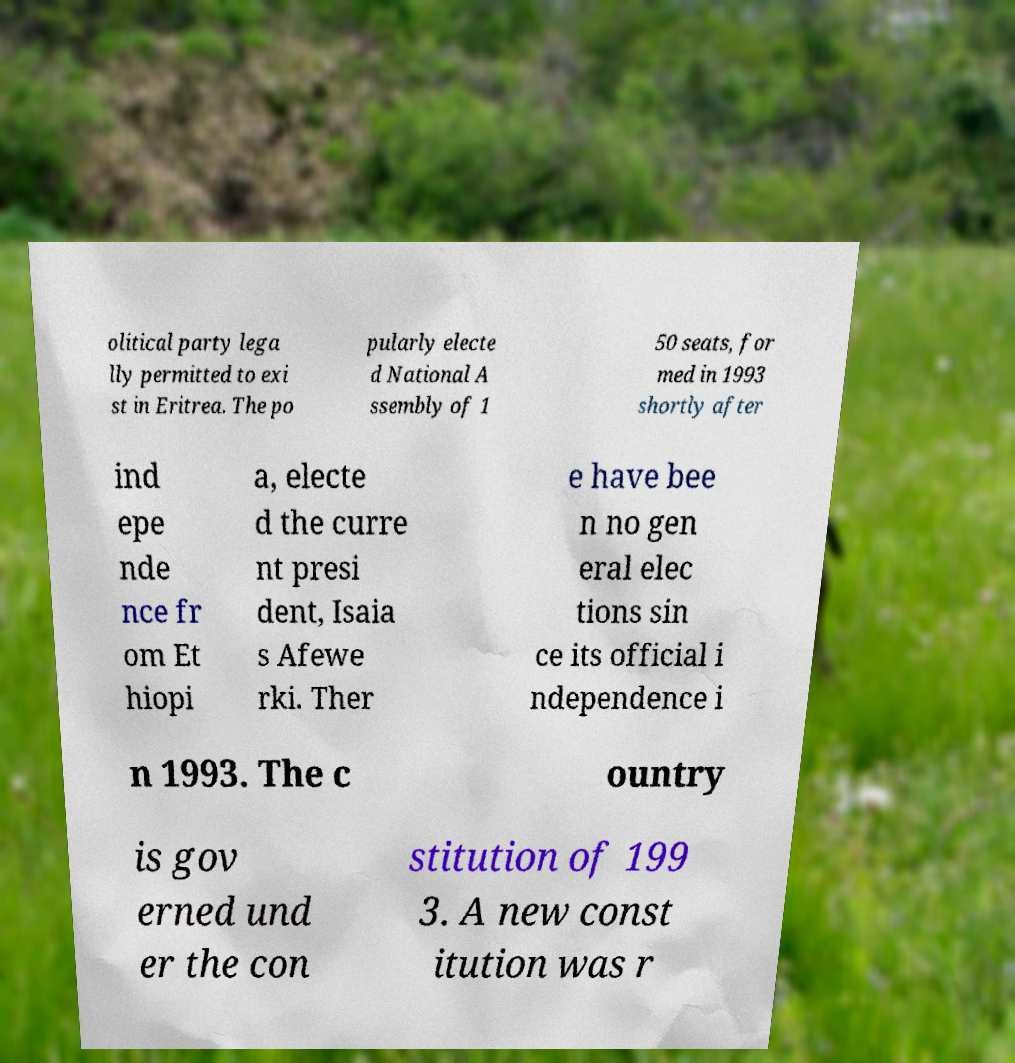Can you read and provide the text displayed in the image?This photo seems to have some interesting text. Can you extract and type it out for me? olitical party lega lly permitted to exi st in Eritrea. The po pularly electe d National A ssembly of 1 50 seats, for med in 1993 shortly after ind epe nde nce fr om Et hiopi a, electe d the curre nt presi dent, Isaia s Afewe rki. Ther e have bee n no gen eral elec tions sin ce its official i ndependence i n 1993. The c ountry is gov erned und er the con stitution of 199 3. A new const itution was r 